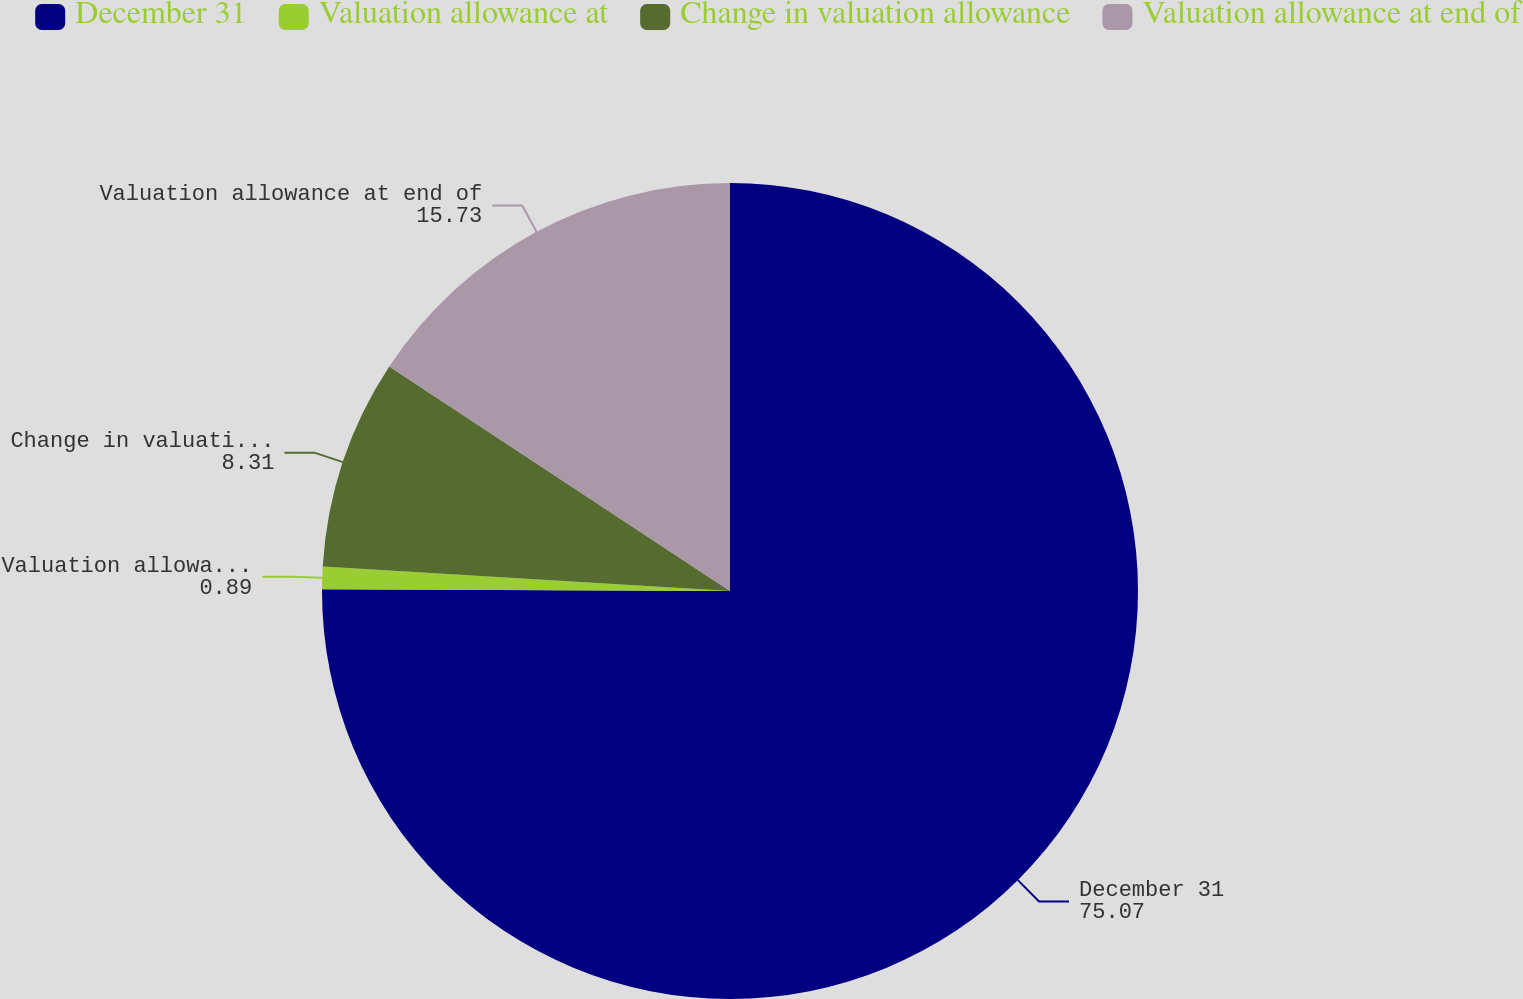<chart> <loc_0><loc_0><loc_500><loc_500><pie_chart><fcel>December 31<fcel>Valuation allowance at<fcel>Change in valuation allowance<fcel>Valuation allowance at end of<nl><fcel>75.07%<fcel>0.89%<fcel>8.31%<fcel>15.73%<nl></chart> 